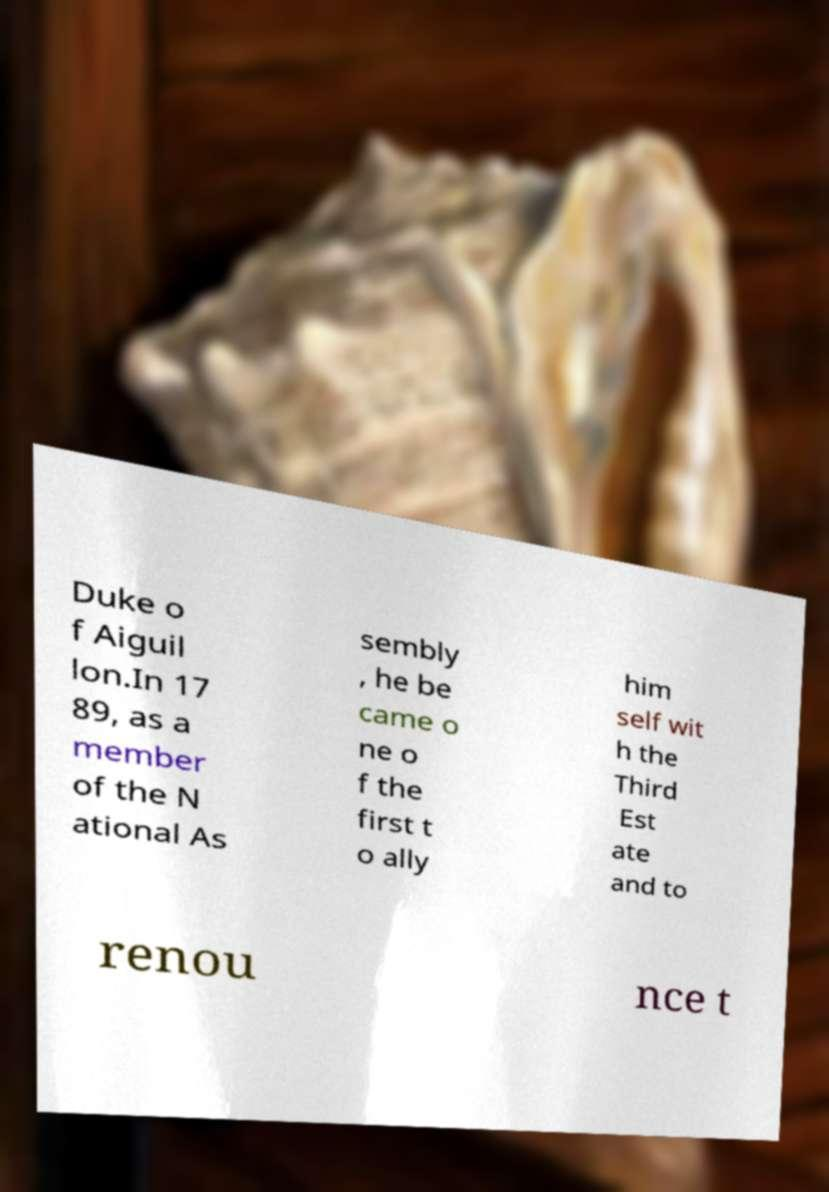Please identify and transcribe the text found in this image. Duke o f Aiguil lon.In 17 89, as a member of the N ational As sembly , he be came o ne o f the first t o ally him self wit h the Third Est ate and to renou nce t 